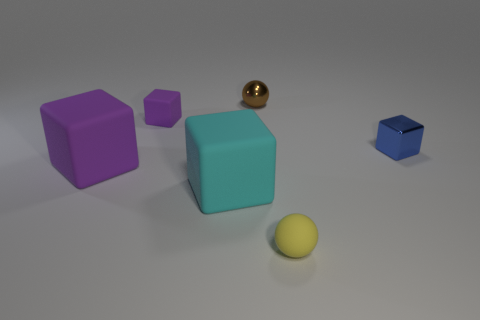What do you think the texture of the large turquoise block might feel like? The large turquoise block has a smooth and matte finish, suggesting that it would have a solid and even texture to the touch, likely cool and firm given its appearance. 